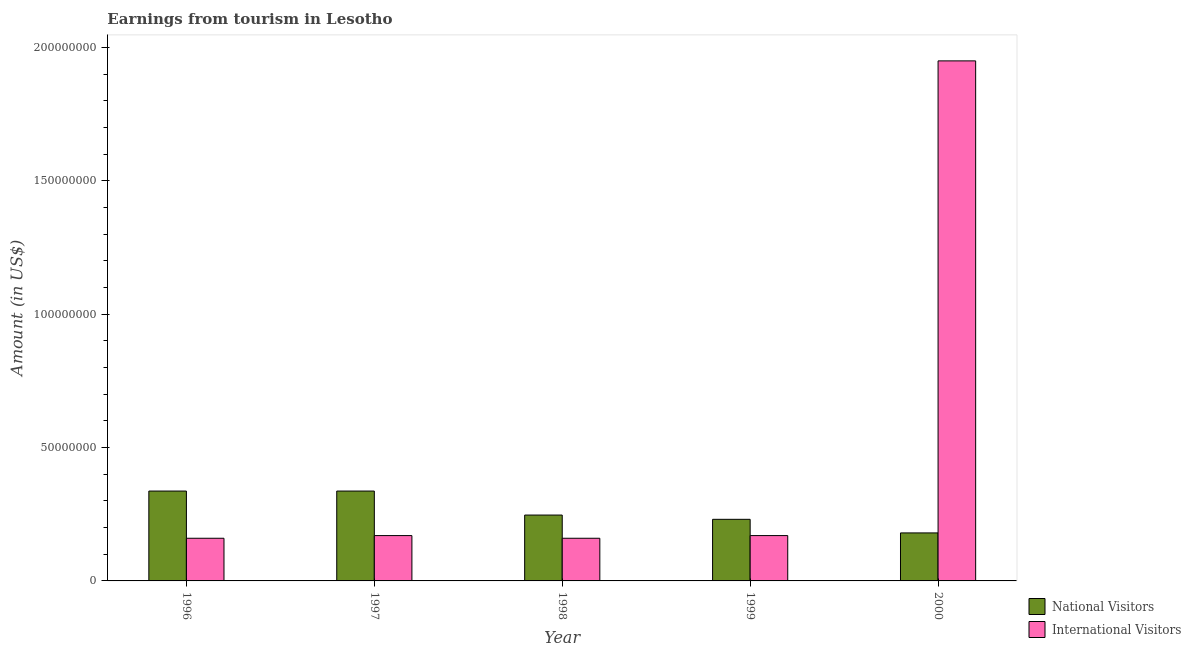How many groups of bars are there?
Offer a terse response. 5. Are the number of bars per tick equal to the number of legend labels?
Offer a very short reply. Yes. How many bars are there on the 3rd tick from the left?
Your answer should be very brief. 2. What is the amount earned from national visitors in 2000?
Give a very brief answer. 1.80e+07. Across all years, what is the maximum amount earned from international visitors?
Your answer should be very brief. 1.95e+08. Across all years, what is the minimum amount earned from international visitors?
Provide a succinct answer. 1.60e+07. In which year was the amount earned from international visitors minimum?
Provide a succinct answer. 1996. What is the total amount earned from national visitors in the graph?
Ensure brevity in your answer.  1.33e+08. What is the difference between the amount earned from international visitors in 1996 and that in 1999?
Offer a terse response. -1.00e+06. What is the difference between the amount earned from national visitors in 2000 and the amount earned from international visitors in 1999?
Make the answer very short. -5.10e+06. What is the average amount earned from international visitors per year?
Keep it short and to the point. 5.22e+07. In how many years, is the amount earned from international visitors greater than 180000000 US$?
Give a very brief answer. 1. What is the ratio of the amount earned from national visitors in 1999 to that in 2000?
Give a very brief answer. 1.28. Is the amount earned from international visitors in 1999 less than that in 2000?
Keep it short and to the point. Yes. What is the difference between the highest and the second highest amount earned from international visitors?
Your answer should be compact. 1.78e+08. What is the difference between the highest and the lowest amount earned from international visitors?
Give a very brief answer. 1.79e+08. In how many years, is the amount earned from national visitors greater than the average amount earned from national visitors taken over all years?
Offer a very short reply. 2. What does the 2nd bar from the left in 1996 represents?
Your response must be concise. International Visitors. What does the 1st bar from the right in 2000 represents?
Give a very brief answer. International Visitors. Are all the bars in the graph horizontal?
Offer a very short reply. No. How many years are there in the graph?
Keep it short and to the point. 5. Does the graph contain any zero values?
Your response must be concise. No. Does the graph contain grids?
Provide a short and direct response. No. How many legend labels are there?
Ensure brevity in your answer.  2. What is the title of the graph?
Your response must be concise. Earnings from tourism in Lesotho. Does "Personal remittances" appear as one of the legend labels in the graph?
Offer a terse response. No. What is the label or title of the X-axis?
Provide a short and direct response. Year. What is the Amount (in US$) in National Visitors in 1996?
Your response must be concise. 3.37e+07. What is the Amount (in US$) of International Visitors in 1996?
Make the answer very short. 1.60e+07. What is the Amount (in US$) of National Visitors in 1997?
Your answer should be compact. 3.37e+07. What is the Amount (in US$) in International Visitors in 1997?
Provide a succinct answer. 1.70e+07. What is the Amount (in US$) of National Visitors in 1998?
Keep it short and to the point. 2.47e+07. What is the Amount (in US$) in International Visitors in 1998?
Your answer should be very brief. 1.60e+07. What is the Amount (in US$) in National Visitors in 1999?
Offer a very short reply. 2.31e+07. What is the Amount (in US$) in International Visitors in 1999?
Offer a very short reply. 1.70e+07. What is the Amount (in US$) of National Visitors in 2000?
Provide a short and direct response. 1.80e+07. What is the Amount (in US$) in International Visitors in 2000?
Provide a succinct answer. 1.95e+08. Across all years, what is the maximum Amount (in US$) of National Visitors?
Offer a terse response. 3.37e+07. Across all years, what is the maximum Amount (in US$) in International Visitors?
Offer a very short reply. 1.95e+08. Across all years, what is the minimum Amount (in US$) of National Visitors?
Provide a succinct answer. 1.80e+07. Across all years, what is the minimum Amount (in US$) of International Visitors?
Provide a short and direct response. 1.60e+07. What is the total Amount (in US$) in National Visitors in the graph?
Give a very brief answer. 1.33e+08. What is the total Amount (in US$) in International Visitors in the graph?
Your answer should be compact. 2.61e+08. What is the difference between the Amount (in US$) in National Visitors in 1996 and that in 1998?
Give a very brief answer. 9.00e+06. What is the difference between the Amount (in US$) in International Visitors in 1996 and that in 1998?
Your response must be concise. 0. What is the difference between the Amount (in US$) in National Visitors in 1996 and that in 1999?
Offer a terse response. 1.06e+07. What is the difference between the Amount (in US$) in National Visitors in 1996 and that in 2000?
Offer a terse response. 1.57e+07. What is the difference between the Amount (in US$) in International Visitors in 1996 and that in 2000?
Offer a very short reply. -1.79e+08. What is the difference between the Amount (in US$) of National Visitors in 1997 and that in 1998?
Keep it short and to the point. 9.00e+06. What is the difference between the Amount (in US$) in National Visitors in 1997 and that in 1999?
Provide a short and direct response. 1.06e+07. What is the difference between the Amount (in US$) in National Visitors in 1997 and that in 2000?
Give a very brief answer. 1.57e+07. What is the difference between the Amount (in US$) in International Visitors in 1997 and that in 2000?
Offer a terse response. -1.78e+08. What is the difference between the Amount (in US$) of National Visitors in 1998 and that in 1999?
Your answer should be compact. 1.60e+06. What is the difference between the Amount (in US$) of International Visitors in 1998 and that in 1999?
Give a very brief answer. -1.00e+06. What is the difference between the Amount (in US$) in National Visitors in 1998 and that in 2000?
Provide a short and direct response. 6.70e+06. What is the difference between the Amount (in US$) in International Visitors in 1998 and that in 2000?
Give a very brief answer. -1.79e+08. What is the difference between the Amount (in US$) of National Visitors in 1999 and that in 2000?
Provide a succinct answer. 5.10e+06. What is the difference between the Amount (in US$) of International Visitors in 1999 and that in 2000?
Keep it short and to the point. -1.78e+08. What is the difference between the Amount (in US$) of National Visitors in 1996 and the Amount (in US$) of International Visitors in 1997?
Offer a terse response. 1.67e+07. What is the difference between the Amount (in US$) in National Visitors in 1996 and the Amount (in US$) in International Visitors in 1998?
Make the answer very short. 1.77e+07. What is the difference between the Amount (in US$) in National Visitors in 1996 and the Amount (in US$) in International Visitors in 1999?
Provide a succinct answer. 1.67e+07. What is the difference between the Amount (in US$) of National Visitors in 1996 and the Amount (in US$) of International Visitors in 2000?
Provide a succinct answer. -1.61e+08. What is the difference between the Amount (in US$) in National Visitors in 1997 and the Amount (in US$) in International Visitors in 1998?
Ensure brevity in your answer.  1.77e+07. What is the difference between the Amount (in US$) of National Visitors in 1997 and the Amount (in US$) of International Visitors in 1999?
Your answer should be compact. 1.67e+07. What is the difference between the Amount (in US$) of National Visitors in 1997 and the Amount (in US$) of International Visitors in 2000?
Your response must be concise. -1.61e+08. What is the difference between the Amount (in US$) in National Visitors in 1998 and the Amount (in US$) in International Visitors in 1999?
Keep it short and to the point. 7.70e+06. What is the difference between the Amount (in US$) in National Visitors in 1998 and the Amount (in US$) in International Visitors in 2000?
Offer a very short reply. -1.70e+08. What is the difference between the Amount (in US$) of National Visitors in 1999 and the Amount (in US$) of International Visitors in 2000?
Ensure brevity in your answer.  -1.72e+08. What is the average Amount (in US$) in National Visitors per year?
Provide a succinct answer. 2.66e+07. What is the average Amount (in US$) in International Visitors per year?
Keep it short and to the point. 5.22e+07. In the year 1996, what is the difference between the Amount (in US$) in National Visitors and Amount (in US$) in International Visitors?
Provide a short and direct response. 1.77e+07. In the year 1997, what is the difference between the Amount (in US$) of National Visitors and Amount (in US$) of International Visitors?
Make the answer very short. 1.67e+07. In the year 1998, what is the difference between the Amount (in US$) of National Visitors and Amount (in US$) of International Visitors?
Keep it short and to the point. 8.70e+06. In the year 1999, what is the difference between the Amount (in US$) in National Visitors and Amount (in US$) in International Visitors?
Provide a short and direct response. 6.10e+06. In the year 2000, what is the difference between the Amount (in US$) of National Visitors and Amount (in US$) of International Visitors?
Make the answer very short. -1.77e+08. What is the ratio of the Amount (in US$) in National Visitors in 1996 to that in 1998?
Make the answer very short. 1.36. What is the ratio of the Amount (in US$) in International Visitors in 1996 to that in 1998?
Make the answer very short. 1. What is the ratio of the Amount (in US$) in National Visitors in 1996 to that in 1999?
Make the answer very short. 1.46. What is the ratio of the Amount (in US$) of National Visitors in 1996 to that in 2000?
Give a very brief answer. 1.87. What is the ratio of the Amount (in US$) in International Visitors in 1996 to that in 2000?
Your answer should be compact. 0.08. What is the ratio of the Amount (in US$) of National Visitors in 1997 to that in 1998?
Offer a very short reply. 1.36. What is the ratio of the Amount (in US$) in International Visitors in 1997 to that in 1998?
Give a very brief answer. 1.06. What is the ratio of the Amount (in US$) in National Visitors in 1997 to that in 1999?
Provide a short and direct response. 1.46. What is the ratio of the Amount (in US$) in International Visitors in 1997 to that in 1999?
Ensure brevity in your answer.  1. What is the ratio of the Amount (in US$) of National Visitors in 1997 to that in 2000?
Offer a terse response. 1.87. What is the ratio of the Amount (in US$) in International Visitors in 1997 to that in 2000?
Offer a terse response. 0.09. What is the ratio of the Amount (in US$) in National Visitors in 1998 to that in 1999?
Make the answer very short. 1.07. What is the ratio of the Amount (in US$) of National Visitors in 1998 to that in 2000?
Keep it short and to the point. 1.37. What is the ratio of the Amount (in US$) in International Visitors in 1998 to that in 2000?
Provide a succinct answer. 0.08. What is the ratio of the Amount (in US$) of National Visitors in 1999 to that in 2000?
Ensure brevity in your answer.  1.28. What is the ratio of the Amount (in US$) of International Visitors in 1999 to that in 2000?
Your answer should be very brief. 0.09. What is the difference between the highest and the second highest Amount (in US$) in National Visitors?
Offer a very short reply. 0. What is the difference between the highest and the second highest Amount (in US$) of International Visitors?
Provide a short and direct response. 1.78e+08. What is the difference between the highest and the lowest Amount (in US$) in National Visitors?
Offer a very short reply. 1.57e+07. What is the difference between the highest and the lowest Amount (in US$) in International Visitors?
Your answer should be very brief. 1.79e+08. 